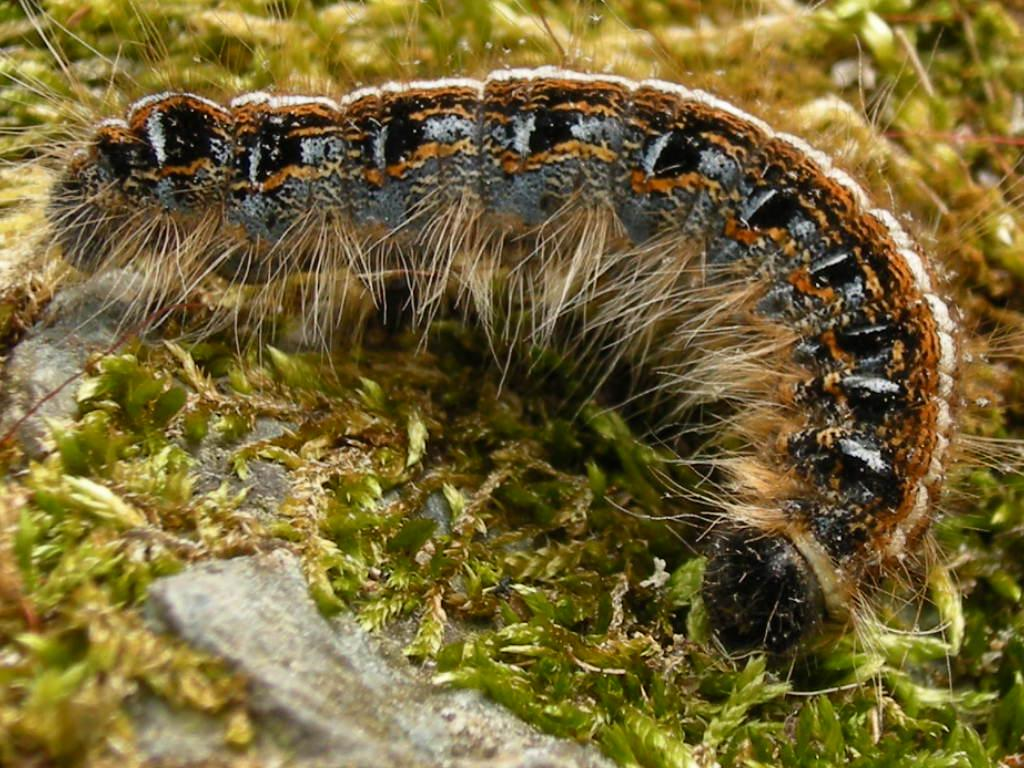Where was the image taken? The image was taken outdoors. What type of surface can be seen on the ground in the image? The ground in the image has grass. What living organism can be seen on the ground in the image? There is an insect on the ground in the image. What is the tendency of the growth of the trees in the image? There are no trees present in the image, so it is not possible to determine the tendency of their growth. 